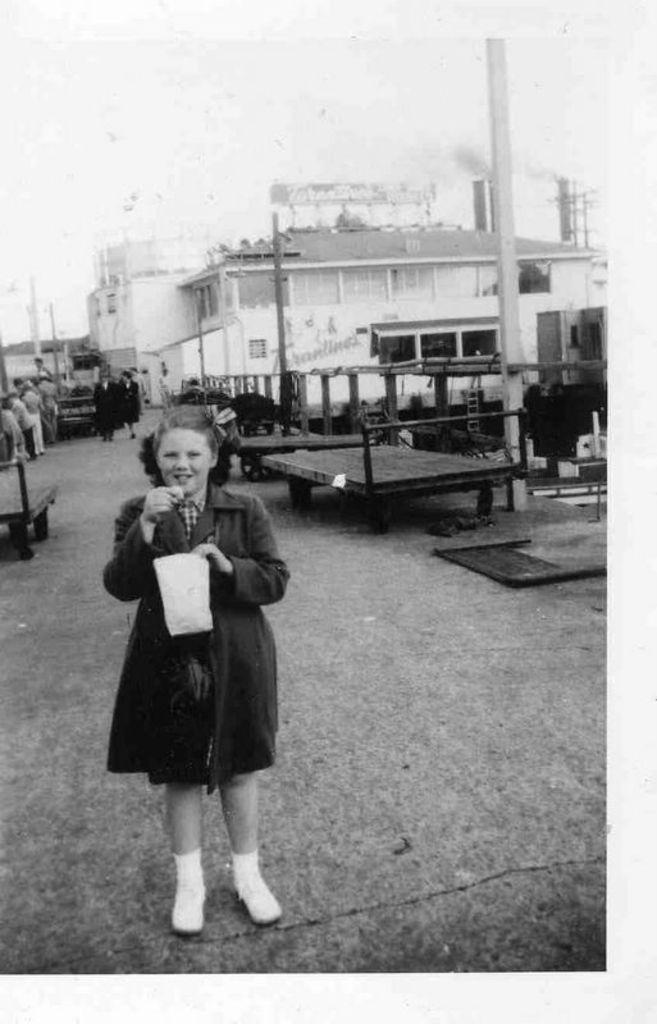Can you describe this image briefly? This is a black and white image and here we can see a girl wearing uniform and holding a packet and a food item. In the background, there are buildings and we can see some other people and some stands. At the top, there is sky and at the bottom, there is a road. 